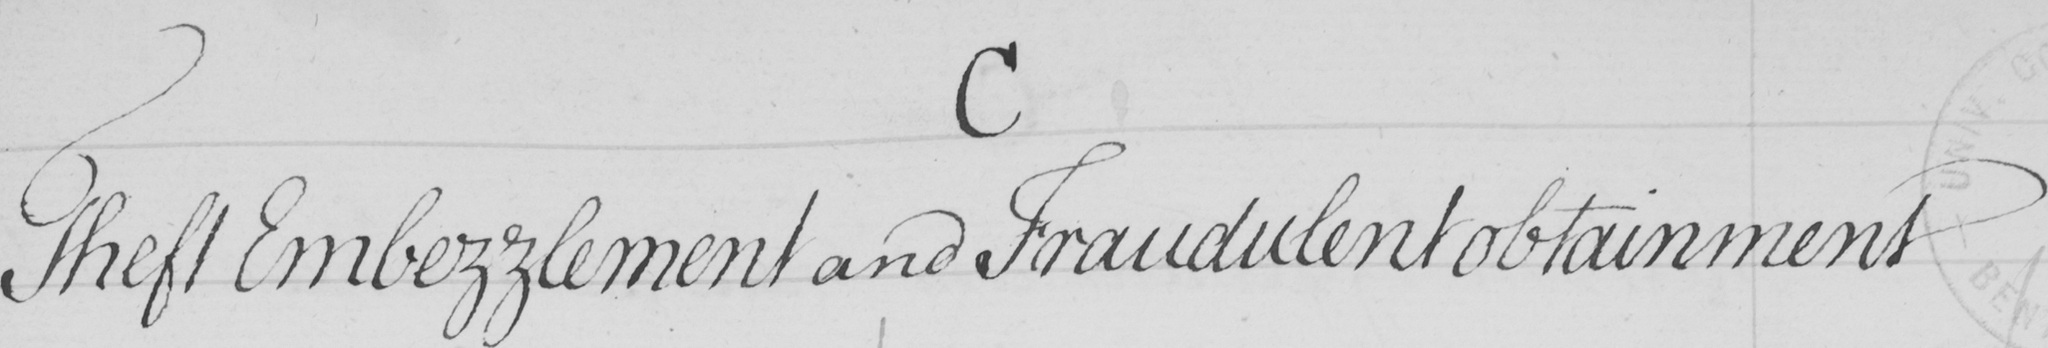What is written in this line of handwriting? Theft Embezzlement and Fraudulent obtainment 